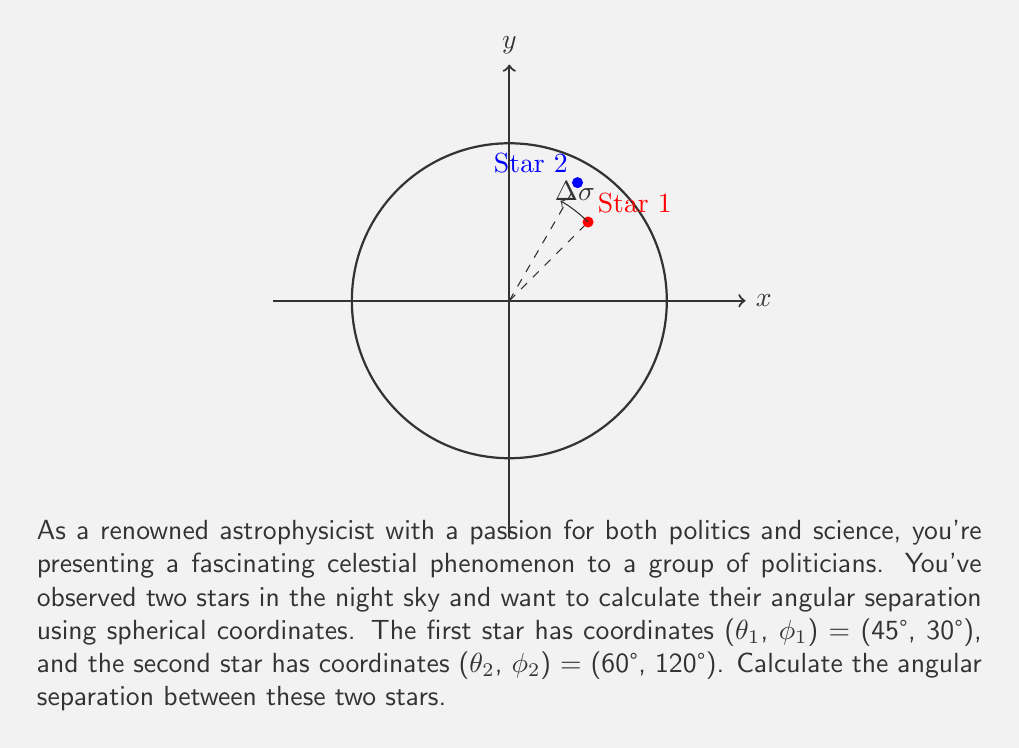Provide a solution to this math problem. To calculate the angular separation between two stars using spherical coordinates, we'll use the spherical law of cosines. The formula for angular separation (Δσ) is:

$$\cos(\Delta\sigma) = \sin(\theta_1)\sin(\theta_2) + \cos(\theta_1)\cos(\theta_2)\cos(\phi_2 - \phi_1)$$

Let's solve this step by step:

1) Convert all angles to radians:
   θ₁ = 45° = π/4 rad
   φ₁ = 30° = π/6 rad
   θ₂ = 60° = π/3 rad
   φ₂ = 120° = 2π/3 rad

2) Calculate (φ₂ - φ₁):
   φ₂ - φ₁ = 2π/3 - π/6 = π/2

3) Substitute these values into the formula:
   $$\cos(\Delta\sigma) = \sin(\pi/4)\sin(\pi/3) + \cos(\pi/4)\cos(\pi/3)\cos(\pi/2)$$

4) Calculate each term:
   $\sin(\pi/4) = 1/\sqrt{2}$
   $\sin(\pi/3) = \sqrt{3}/2$
   $\cos(\pi/4) = 1/\sqrt{2}$
   $\cos(\pi/3) = 1/2$
   $\cos(\pi/2) = 0$

5) Substitute these values:
   $$\cos(\Delta\sigma) = (1/\sqrt{2})(\sqrt{3}/2) + (1/\sqrt{2})(1/2)(0)$$

6) Simplify:
   $$\cos(\Delta\sigma) = \sqrt{3}/2\sqrt{2} \approx 0.6124$$

7) To find Δσ, take the inverse cosine (arccos) of both sides:
   $$\Delta\sigma = \arccos(\sqrt{3}/2\sqrt{2}) \approx 0.9553 \text{ radians}$$

8) Convert to degrees:
   $$\Delta\sigma \approx 0.9553 \times (180/\pi) \approx 54.74°$$
Answer: $54.74°$ 